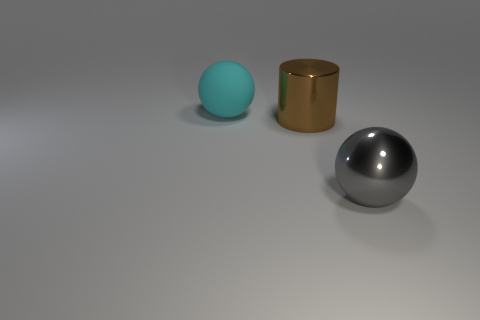Add 1 gray metallic objects. How many objects exist? 4 Subtract all cylinders. How many objects are left? 2 Subtract all red spheres. Subtract all large balls. How many objects are left? 1 Add 2 shiny cylinders. How many shiny cylinders are left? 3 Add 3 big spheres. How many big spheres exist? 5 Subtract 0 brown cubes. How many objects are left? 3 